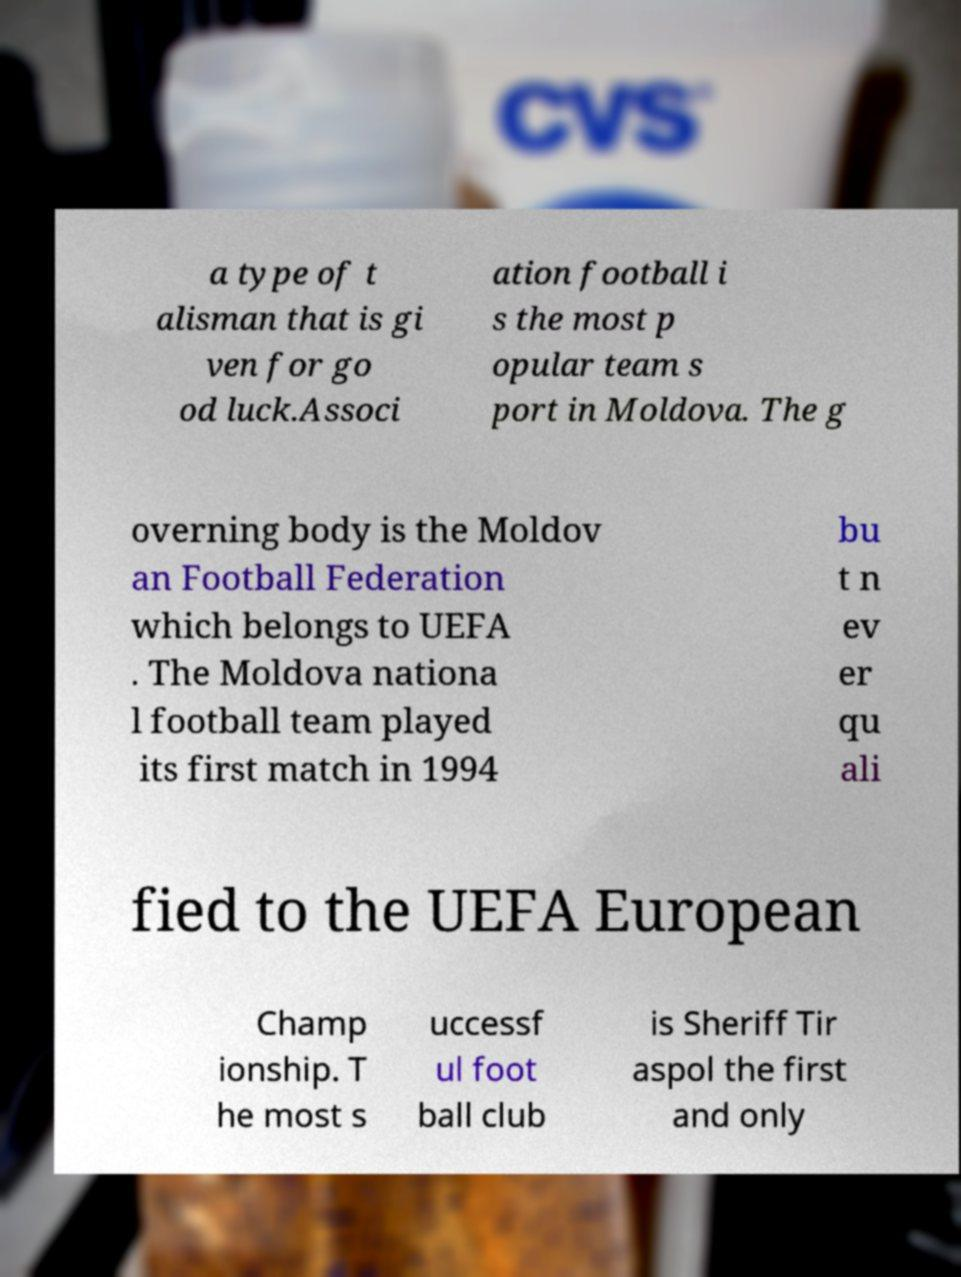Please identify and transcribe the text found in this image. a type of t alisman that is gi ven for go od luck.Associ ation football i s the most p opular team s port in Moldova. The g overning body is the Moldov an Football Federation which belongs to UEFA . The Moldova nationa l football team played its first match in 1994 bu t n ev er qu ali fied to the UEFA European Champ ionship. T he most s uccessf ul foot ball club is Sheriff Tir aspol the first and only 